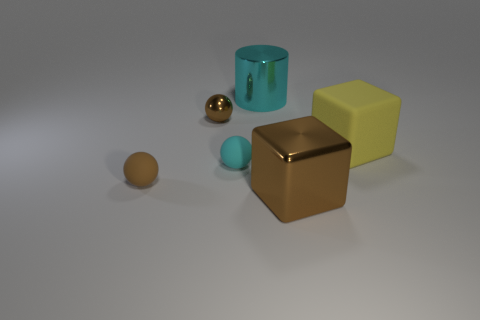Subtract all yellow blocks. How many brown balls are left? 2 Subtract all small brown rubber balls. How many balls are left? 2 Subtract all green spheres. Subtract all purple cylinders. How many spheres are left? 3 Add 4 tiny cyan matte objects. How many objects exist? 10 Subtract all cubes. How many objects are left? 4 Subtract all yellow rubber objects. Subtract all tiny brown metal spheres. How many objects are left? 4 Add 3 yellow matte objects. How many yellow matte objects are left? 4 Add 1 big cubes. How many big cubes exist? 3 Subtract 0 blue balls. How many objects are left? 6 